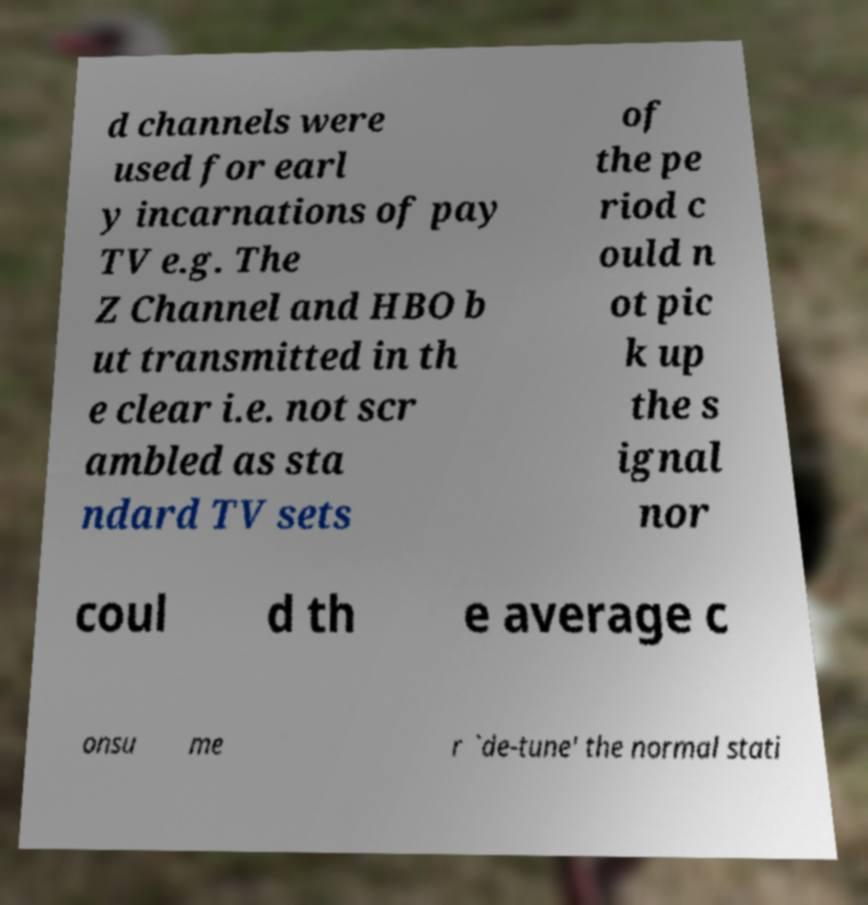Can you read and provide the text displayed in the image?This photo seems to have some interesting text. Can you extract and type it out for me? d channels were used for earl y incarnations of pay TV e.g. The Z Channel and HBO b ut transmitted in th e clear i.e. not scr ambled as sta ndard TV sets of the pe riod c ould n ot pic k up the s ignal nor coul d th e average c onsu me r `de-tune' the normal stati 